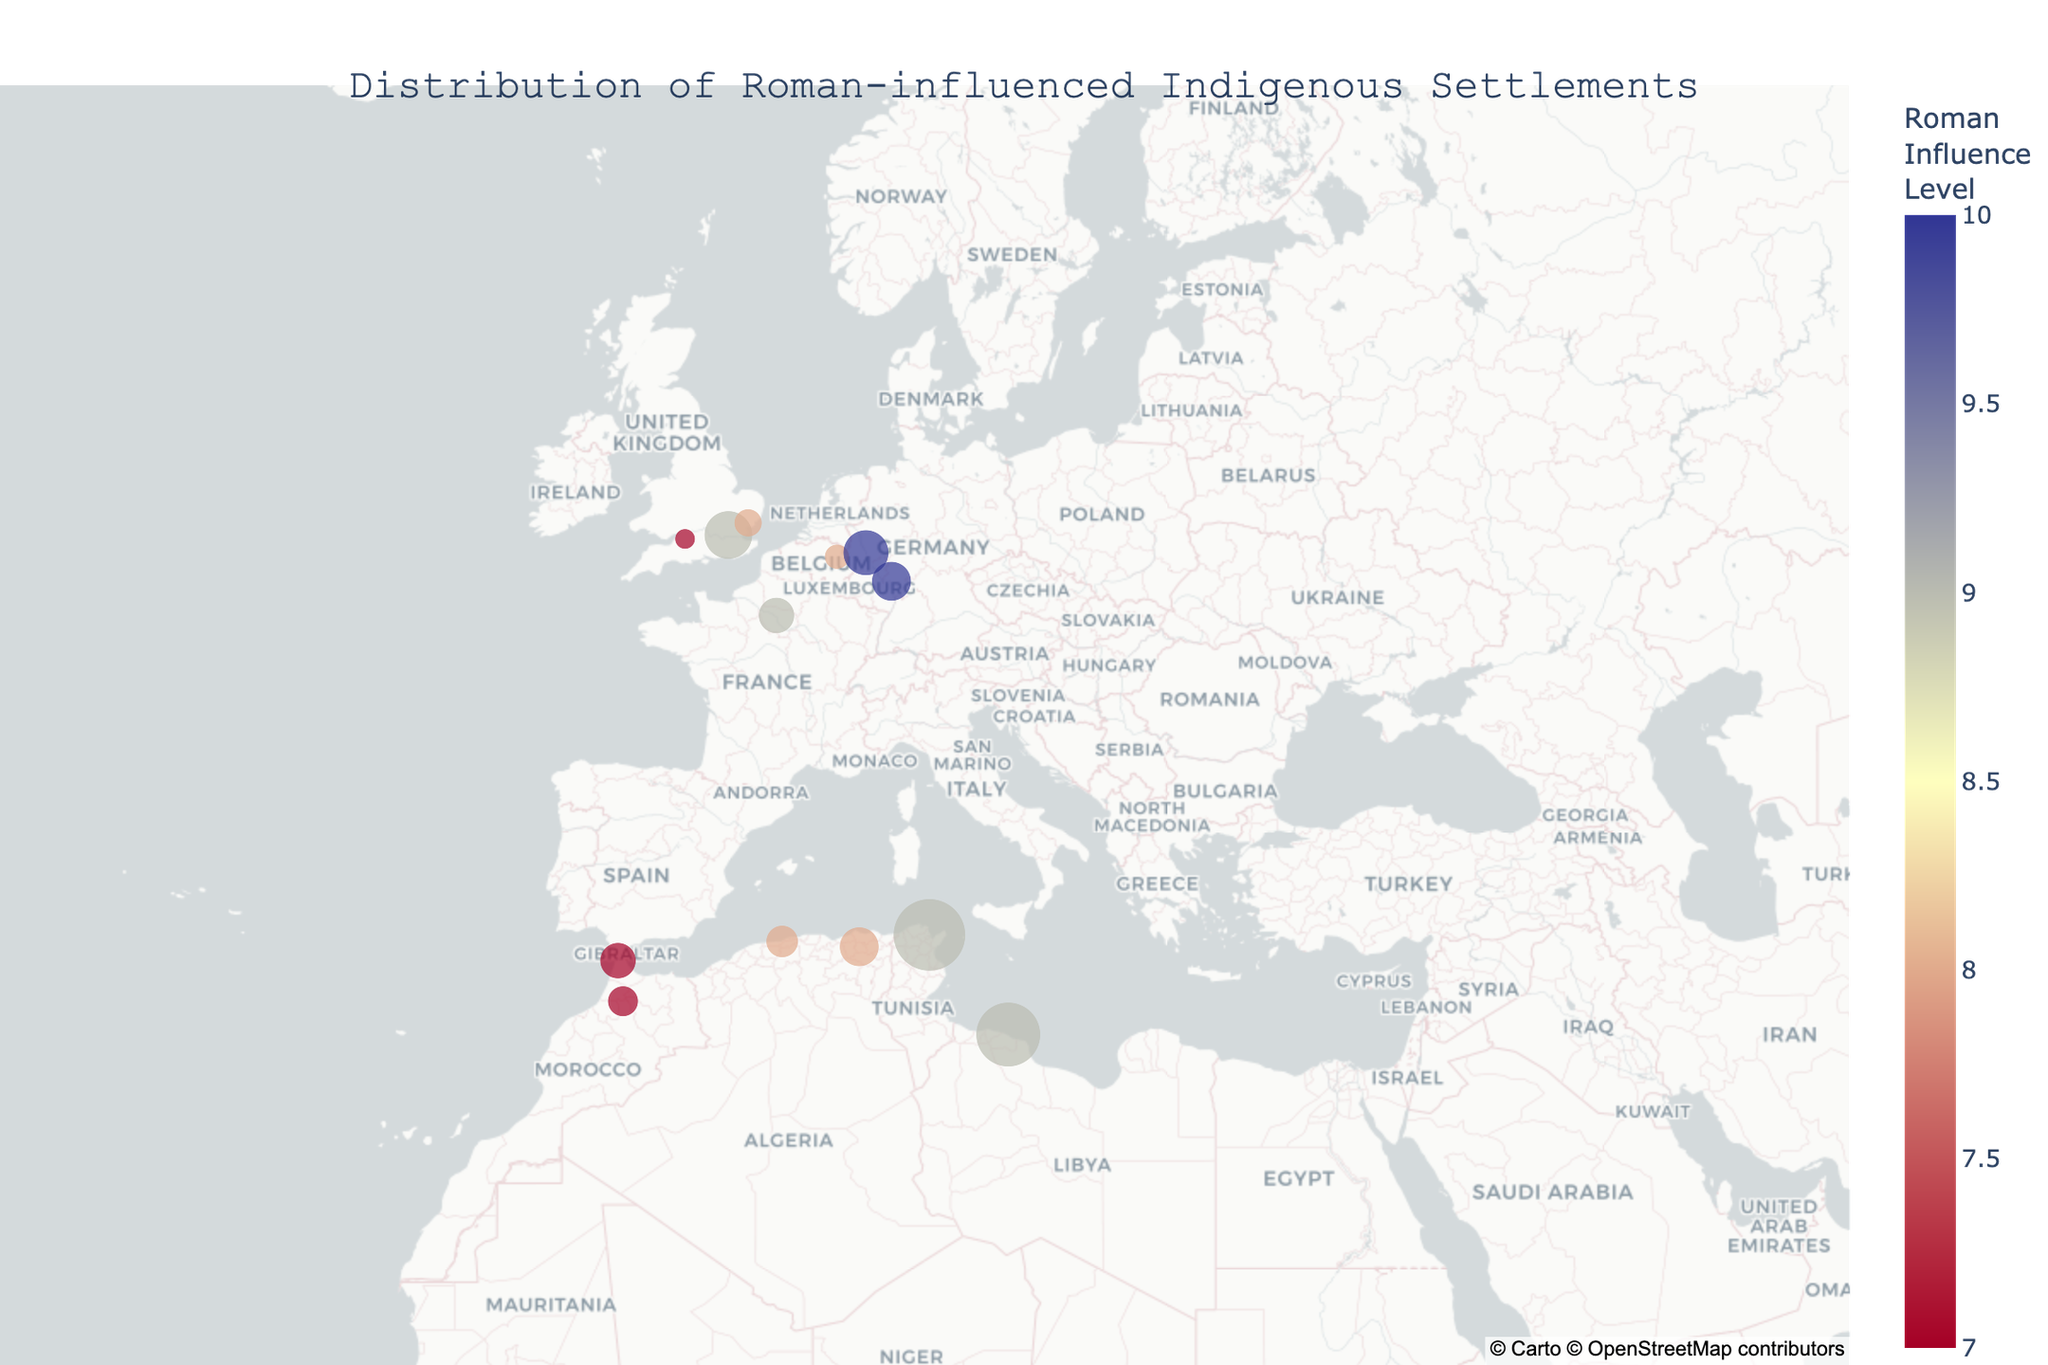What is the title of the figure? Look at the top of the plot where the title is located, it reads "Distribution of Roman-influenced Indigenous Settlements".
Answer: Distribution of Roman-influenced Indigenous Settlements What color represents the highest level of Roman influence? Observe the color bar on the side of the figure; the highest level of Roman influence is indicated by the darkest color at the top of the color scale, which is a deep blue.
Answer: Deep blue How many settlements have a population of less than 20,000? Count the number of points in the plot with a relatively small size, corresponding to settlements with populations of less than 20,000. The settlements are Aquae Sulis, Camulodunum, Volubilis, and Atuatuca Tungrorum.
Answer: Four Which settlement has the largest population and what is it? Look for the largest circle size on the plot, which represents the settlement with the largest population. The largest circle size is for Carthago, indicating a population of 100,000.
Answer: Carthago, 100,000 Which settlement with a Roman Influence Level of 9 is located the northernmost? Identify all settlements with a Roman Influence Level of 9 and look for the one located furthest north on the map. This would be Londinium.
Answer: Londinium What is the average Roman Influence Level for settlements in North Africa? There are four North African settlements: Carthago (9), Caesarea Mauretaniae (8), Leptis Magna (9), and Cirta (8). Summing the levels: (9 + 8 + 9 + 8) = 34, and dividing by 4 settlements gives an average of 34/4.
Answer: 8.5 Which two settlements have the same Roman Influence Level but different population sizes? Compare the settlements for Roman Influence Levels and identify pairs with the same level but different population sizes. Both Londinium and Lutetia have a Roman Influence Level of 9 but population sizes of 45,000 and 25,000 respectively. Detailed comparison confirms these differences.
Answer: Londinium and Lutetia How do the population sizes compare between settlememts in the British Isles? Examine the settlements in the British Isles: Londinium, Aquae Sulis, and Camulodunum. Londinium has 45,000, Aquae Sulis has 8,000, and Camulodunum has 15,000. Thus Londinium > Camulodunum > Aquae Sulis.
Answer: Londinium > Camulodunum > Aquae Sulis What is the range of populations for settlements with a Roman Influence Level of 7? Identify the settlements with a Roman Influence Level of 7: Aquae Sulis (8,000), Volubilis (18,000), and Tingis (25,000). The smallest population is 8,000 and the largest is 25,000. Therefore, the range is 25,000 - 8,000.
Answer: 17,000 